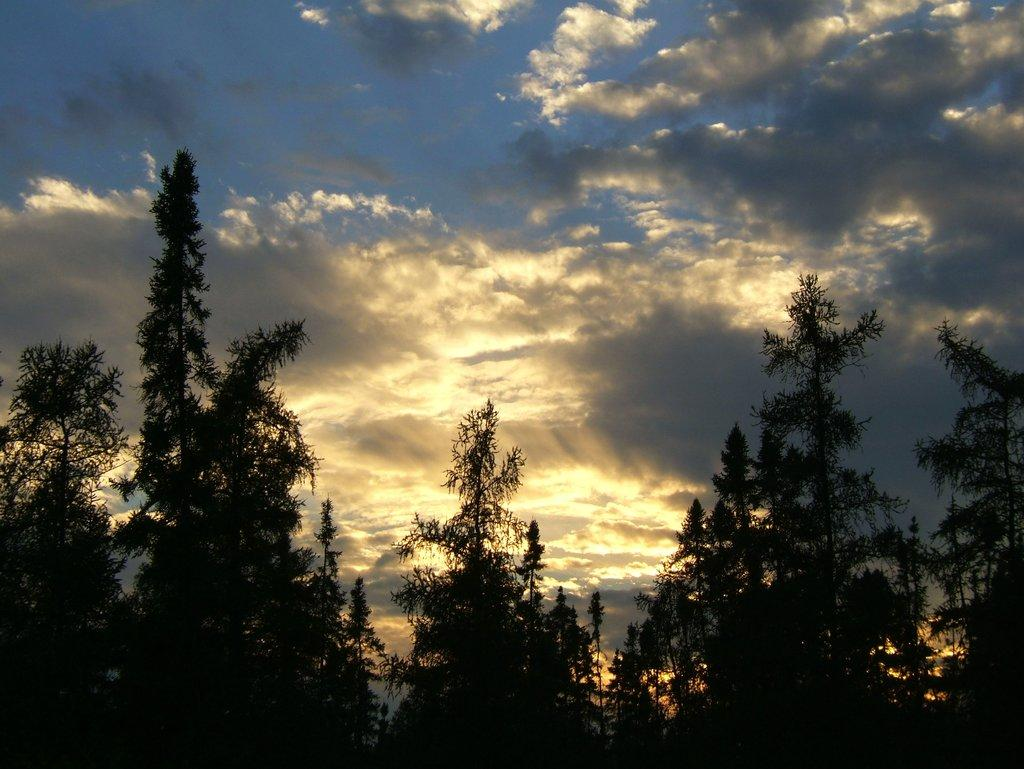What is the primary feature of the image? The primary feature of the image is the presence of many trees. What can be observed in the sky in the image? The sky is cloudy in the image. What type of locket can be seen hanging from a branch in the image? There is no locket present in the image, and no branches are visible. How many yards of fabric are used to create the trees in the image? The trees in the image are real, not fabricated, so there is no fabric or yardage involved. 